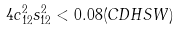Convert formula to latex. <formula><loc_0><loc_0><loc_500><loc_500>4 c _ { 1 2 } ^ { 2 } s _ { 1 2 } ^ { 2 } < 0 . 0 8 ( C D H S W )</formula> 